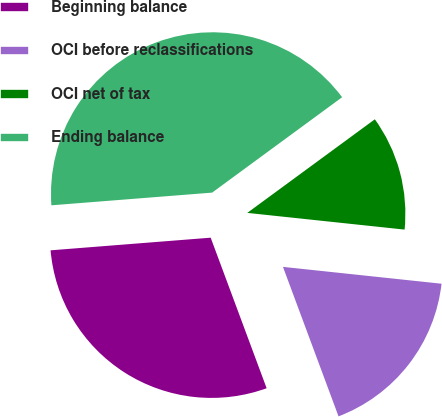Convert chart to OTSL. <chart><loc_0><loc_0><loc_500><loc_500><pie_chart><fcel>Beginning balance<fcel>OCI before reclassifications<fcel>OCI net of tax<fcel>Ending balance<nl><fcel>29.41%<fcel>17.65%<fcel>11.76%<fcel>41.18%<nl></chart> 